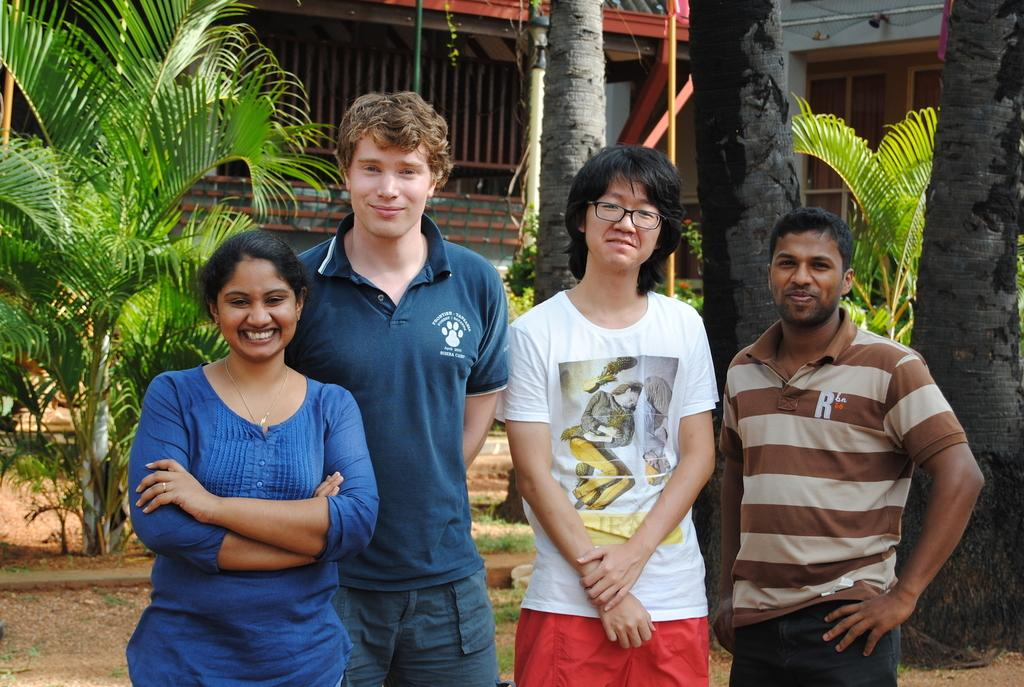What are the people in the image doing? The people in the image are standing and smiling. What can be seen in the background of the image? There are trees, buildings with walls, windows, and rods in the background of the image. Can you tell me how many yaks are visible in the image? There are no yaks present in the image. What type of balloon is being used by the people in the image? There is no balloon present in the image. 